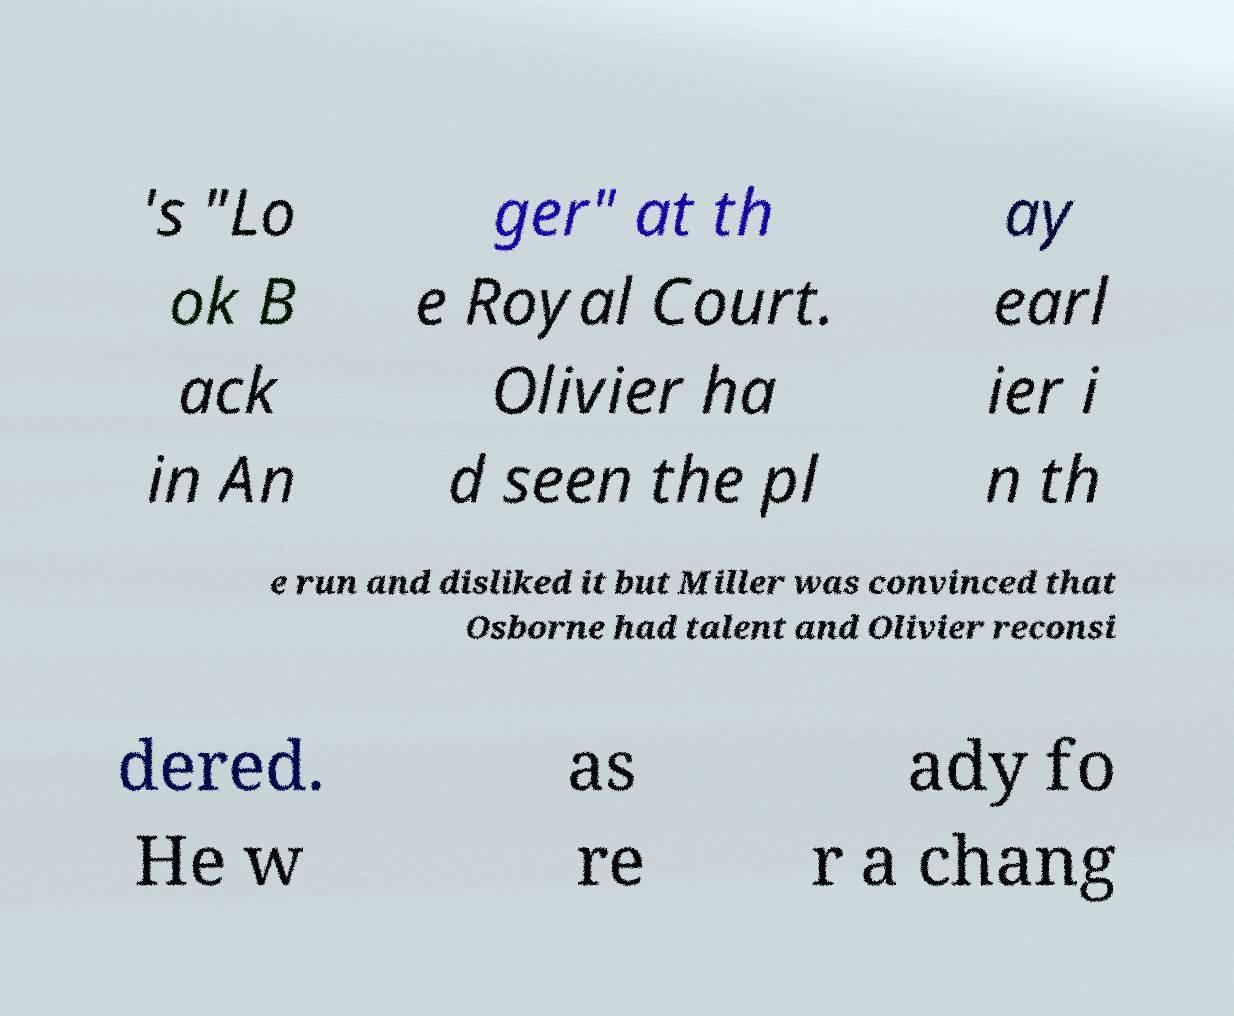Can you read and provide the text displayed in the image?This photo seems to have some interesting text. Can you extract and type it out for me? 's "Lo ok B ack in An ger" at th e Royal Court. Olivier ha d seen the pl ay earl ier i n th e run and disliked it but Miller was convinced that Osborne had talent and Olivier reconsi dered. He w as re ady fo r a chang 